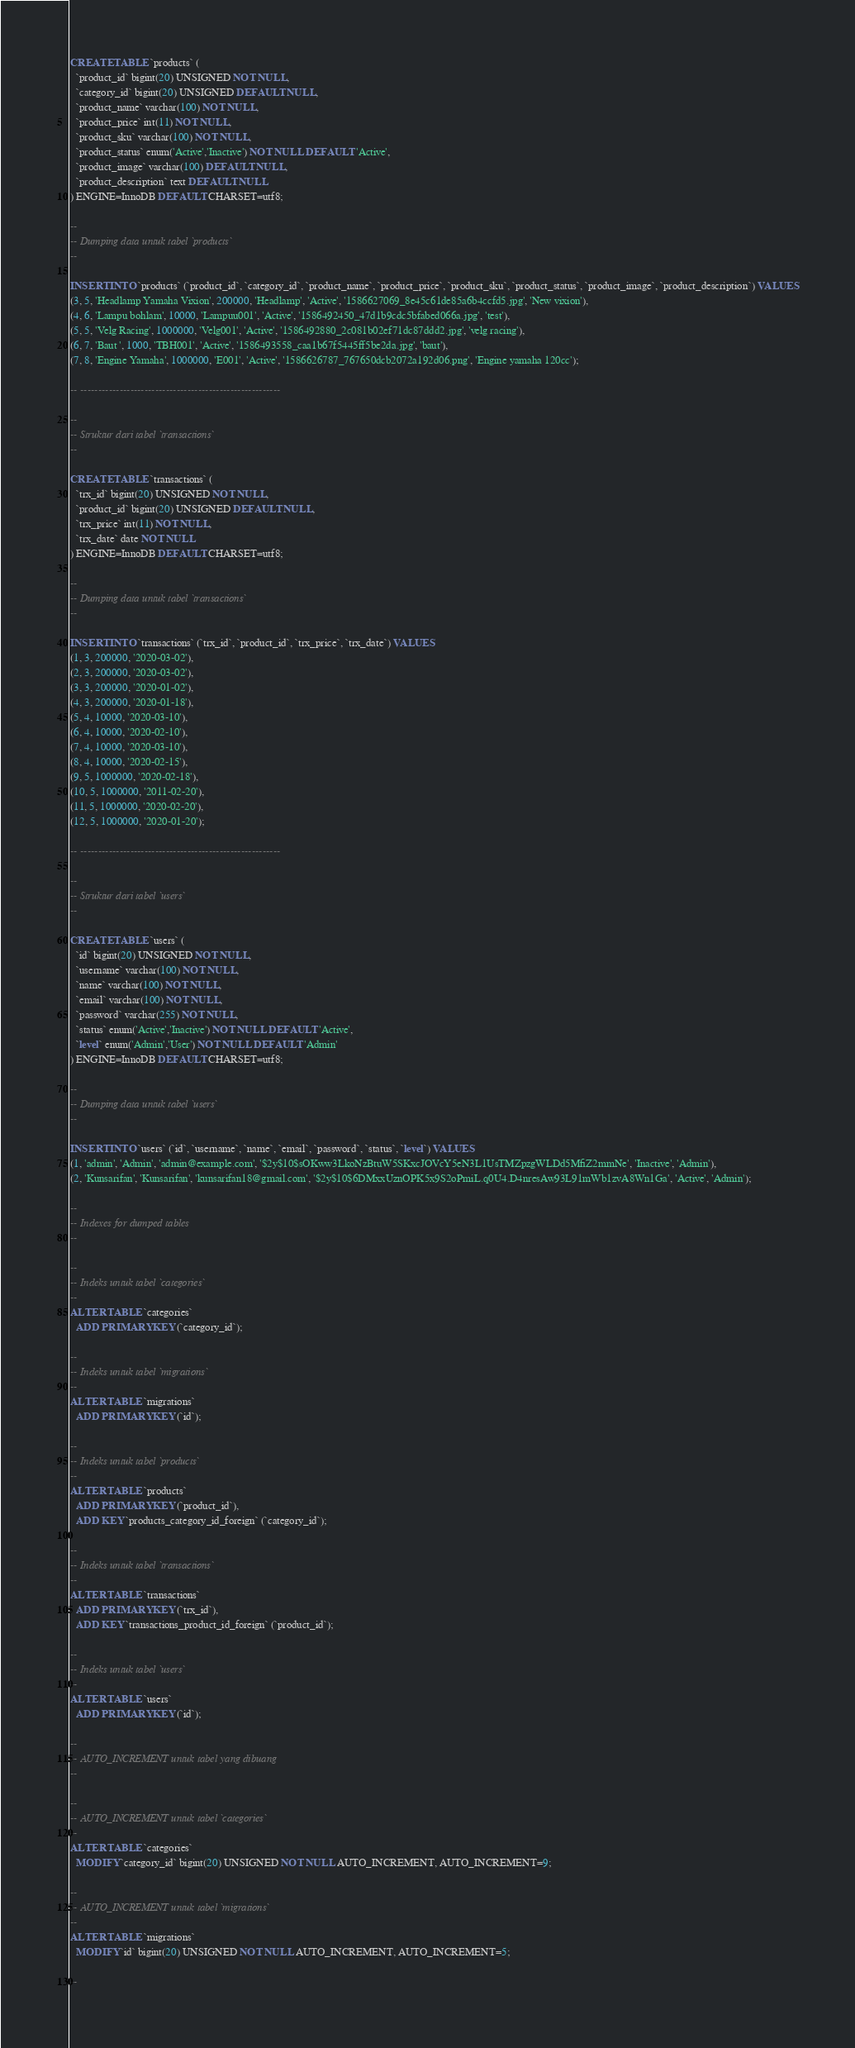<code> <loc_0><loc_0><loc_500><loc_500><_SQL_>
CREATE TABLE `products` (
  `product_id` bigint(20) UNSIGNED NOT NULL,
  `category_id` bigint(20) UNSIGNED DEFAULT NULL,
  `product_name` varchar(100) NOT NULL,
  `product_price` int(11) NOT NULL,
  `product_sku` varchar(100) NOT NULL,
  `product_status` enum('Active','Inactive') NOT NULL DEFAULT 'Active',
  `product_image` varchar(100) DEFAULT NULL,
  `product_description` text DEFAULT NULL
) ENGINE=InnoDB DEFAULT CHARSET=utf8;

--
-- Dumping data untuk tabel `products`
--

INSERT INTO `products` (`product_id`, `category_id`, `product_name`, `product_price`, `product_sku`, `product_status`, `product_image`, `product_description`) VALUES
(3, 5, 'Headlamp Yamaha Vixion', 200000, 'Headlamp', 'Active', '1586627069_8e45c61de85a6b4ccfd5.jpg', 'New vixion'),
(4, 6, 'Lampu bohlam', 10000, 'Lampuu001', 'Active', '1586492450_47d1b9cdc5bfabed066a.jpg', 'test'),
(5, 5, 'Velg Racing', 1000000, 'Velg001', 'Active', '1586492880_2c081b02ef71dc87ddd2.jpg', 'velg racing'),
(6, 7, 'Baut ', 1000, 'TBH001', 'Active', '1586493558_caa1b67f5445ff5be2da.jpg', 'baut'),
(7, 8, 'Engine Yamaha', 1000000, 'E001', 'Active', '1586626787_767650dcb2072a192d06.png', 'Engine yamaha 120cc');

-- --------------------------------------------------------

--
-- Struktur dari tabel `transactions`
--

CREATE TABLE `transactions` (
  `trx_id` bigint(20) UNSIGNED NOT NULL,
  `product_id` bigint(20) UNSIGNED DEFAULT NULL,
  `trx_price` int(11) NOT NULL,
  `trx_date` date NOT NULL
) ENGINE=InnoDB DEFAULT CHARSET=utf8;

--
-- Dumping data untuk tabel `transactions`
--

INSERT INTO `transactions` (`trx_id`, `product_id`, `trx_price`, `trx_date`) VALUES
(1, 3, 200000, '2020-03-02'),
(2, 3, 200000, '2020-03-02'),
(3, 3, 200000, '2020-01-02'),
(4, 3, 200000, '2020-01-18'),
(5, 4, 10000, '2020-03-10'),
(6, 4, 10000, '2020-02-10'),
(7, 4, 10000, '2020-03-10'),
(8, 4, 10000, '2020-02-15'),
(9, 5, 1000000, '2020-02-18'),
(10, 5, 1000000, '2011-02-20'),
(11, 5, 1000000, '2020-02-20'),
(12, 5, 1000000, '2020-01-20');

-- --------------------------------------------------------

--
-- Struktur dari tabel `users`
--

CREATE TABLE `users` (
  `id` bigint(20) UNSIGNED NOT NULL,
  `username` varchar(100) NOT NULL,
  `name` varchar(100) NOT NULL,
  `email` varchar(100) NOT NULL,
  `password` varchar(255) NOT NULL,
  `status` enum('Active','Inactive') NOT NULL DEFAULT 'Active',
  `level` enum('Admin','User') NOT NULL DEFAULT 'Admin'
) ENGINE=InnoDB DEFAULT CHARSET=utf8;

--
-- Dumping data untuk tabel `users`
--

INSERT INTO `users` (`id`, `username`, `name`, `email`, `password`, `status`, `level`) VALUES
(1, 'admin', 'Admin', 'admin@example.com', '$2y$10$sOKww3LkoNzBtuW5SKxcJOVcY5eN3L1UsTMZpzgWLDd5MfiZ2mmNe', 'Inactive', 'Admin'),
(2, 'Kunsarifan', 'Kunsarifan', 'kunsarifan18@gmail.com', '$2y$10$6DMxxUznOPK5x9S2oPmiL.q0U4.D4nresAw93L91mWb1zvA8Wn1Ga', 'Active', 'Admin');

--
-- Indexes for dumped tables
--

--
-- Indeks untuk tabel `categories`
--
ALTER TABLE `categories`
  ADD PRIMARY KEY (`category_id`);

--
-- Indeks untuk tabel `migrations`
--
ALTER TABLE `migrations`
  ADD PRIMARY KEY (`id`);

--
-- Indeks untuk tabel `products`
--
ALTER TABLE `products`
  ADD PRIMARY KEY (`product_id`),
  ADD KEY `products_category_id_foreign` (`category_id`);

--
-- Indeks untuk tabel `transactions`
--
ALTER TABLE `transactions`
  ADD PRIMARY KEY (`trx_id`),
  ADD KEY `transactions_product_id_foreign` (`product_id`);

--
-- Indeks untuk tabel `users`
--
ALTER TABLE `users`
  ADD PRIMARY KEY (`id`);

--
-- AUTO_INCREMENT untuk tabel yang dibuang
--

--
-- AUTO_INCREMENT untuk tabel `categories`
--
ALTER TABLE `categories`
  MODIFY `category_id` bigint(20) UNSIGNED NOT NULL AUTO_INCREMENT, AUTO_INCREMENT=9;

--
-- AUTO_INCREMENT untuk tabel `migrations`
--
ALTER TABLE `migrations`
  MODIFY `id` bigint(20) UNSIGNED NOT NULL AUTO_INCREMENT, AUTO_INCREMENT=5;

--</code> 